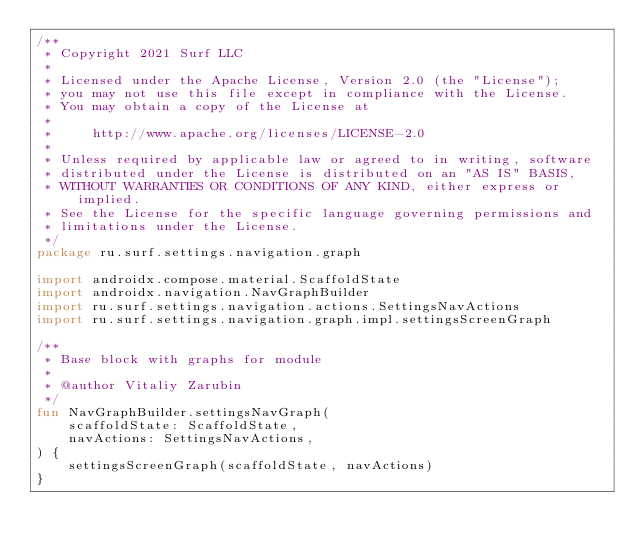Convert code to text. <code><loc_0><loc_0><loc_500><loc_500><_Kotlin_>/**
 * Copyright 2021 Surf LLC
 *
 * Licensed under the Apache License, Version 2.0 (the "License");
 * you may not use this file except in compliance with the License.
 * You may obtain a copy of the License at
 *
 *     http://www.apache.org/licenses/LICENSE-2.0
 *
 * Unless required by applicable law or agreed to in writing, software
 * distributed under the License is distributed on an "AS IS" BASIS,
 * WITHOUT WARRANTIES OR CONDITIONS OF ANY KIND, either express or implied.
 * See the License for the specific language governing permissions and
 * limitations under the License.
 */
package ru.surf.settings.navigation.graph

import androidx.compose.material.ScaffoldState
import androidx.navigation.NavGraphBuilder
import ru.surf.settings.navigation.actions.SettingsNavActions
import ru.surf.settings.navigation.graph.impl.settingsScreenGraph

/**
 * Base block with graphs for module
 *
 * @author Vitaliy Zarubin
 */
fun NavGraphBuilder.settingsNavGraph(
    scaffoldState: ScaffoldState,
    navActions: SettingsNavActions,
) {
    settingsScreenGraph(scaffoldState, navActions)
}
</code> 